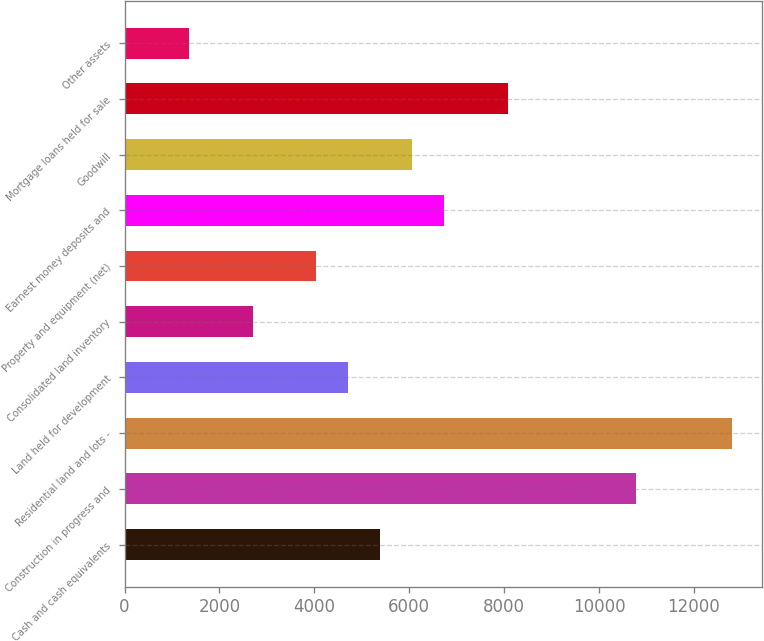Convert chart. <chart><loc_0><loc_0><loc_500><loc_500><bar_chart><fcel>Cash and cash equivalents<fcel>Construction in progress and<fcel>Residential land and lots -<fcel>Land held for development<fcel>Consolidated land inventory<fcel>Property and equipment (net)<fcel>Earnest money deposits and<fcel>Goodwill<fcel>Mortgage loans held for sale<fcel>Other assets<nl><fcel>5390.24<fcel>10777.3<fcel>12797.4<fcel>4716.86<fcel>2696.72<fcel>4043.48<fcel>6737<fcel>6063.62<fcel>8083.76<fcel>1349.96<nl></chart> 